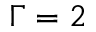Convert formula to latex. <formula><loc_0><loc_0><loc_500><loc_500>\Gamma = 2</formula> 